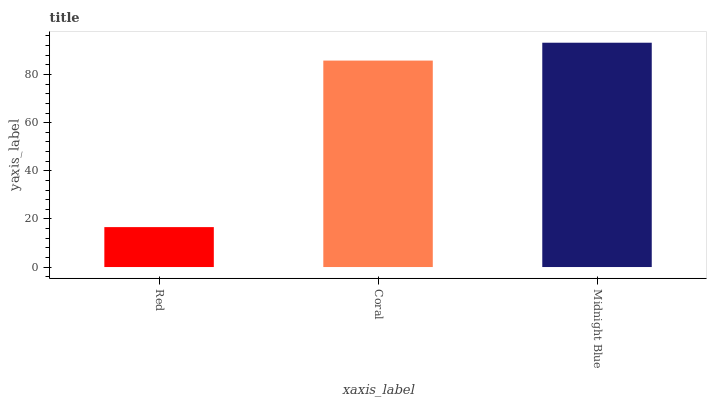Is Coral the minimum?
Answer yes or no. No. Is Coral the maximum?
Answer yes or no. No. Is Coral greater than Red?
Answer yes or no. Yes. Is Red less than Coral?
Answer yes or no. Yes. Is Red greater than Coral?
Answer yes or no. No. Is Coral less than Red?
Answer yes or no. No. Is Coral the high median?
Answer yes or no. Yes. Is Coral the low median?
Answer yes or no. Yes. Is Midnight Blue the high median?
Answer yes or no. No. Is Red the low median?
Answer yes or no. No. 